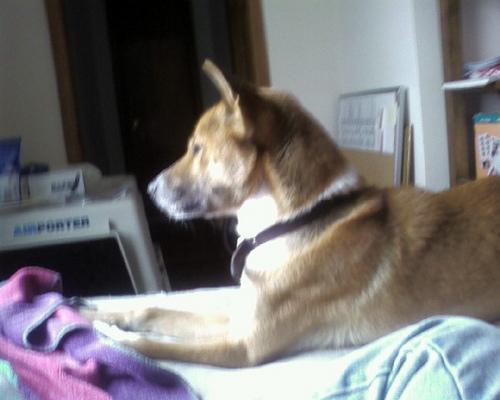How many people are wearing a red shirt?
Give a very brief answer. 0. 